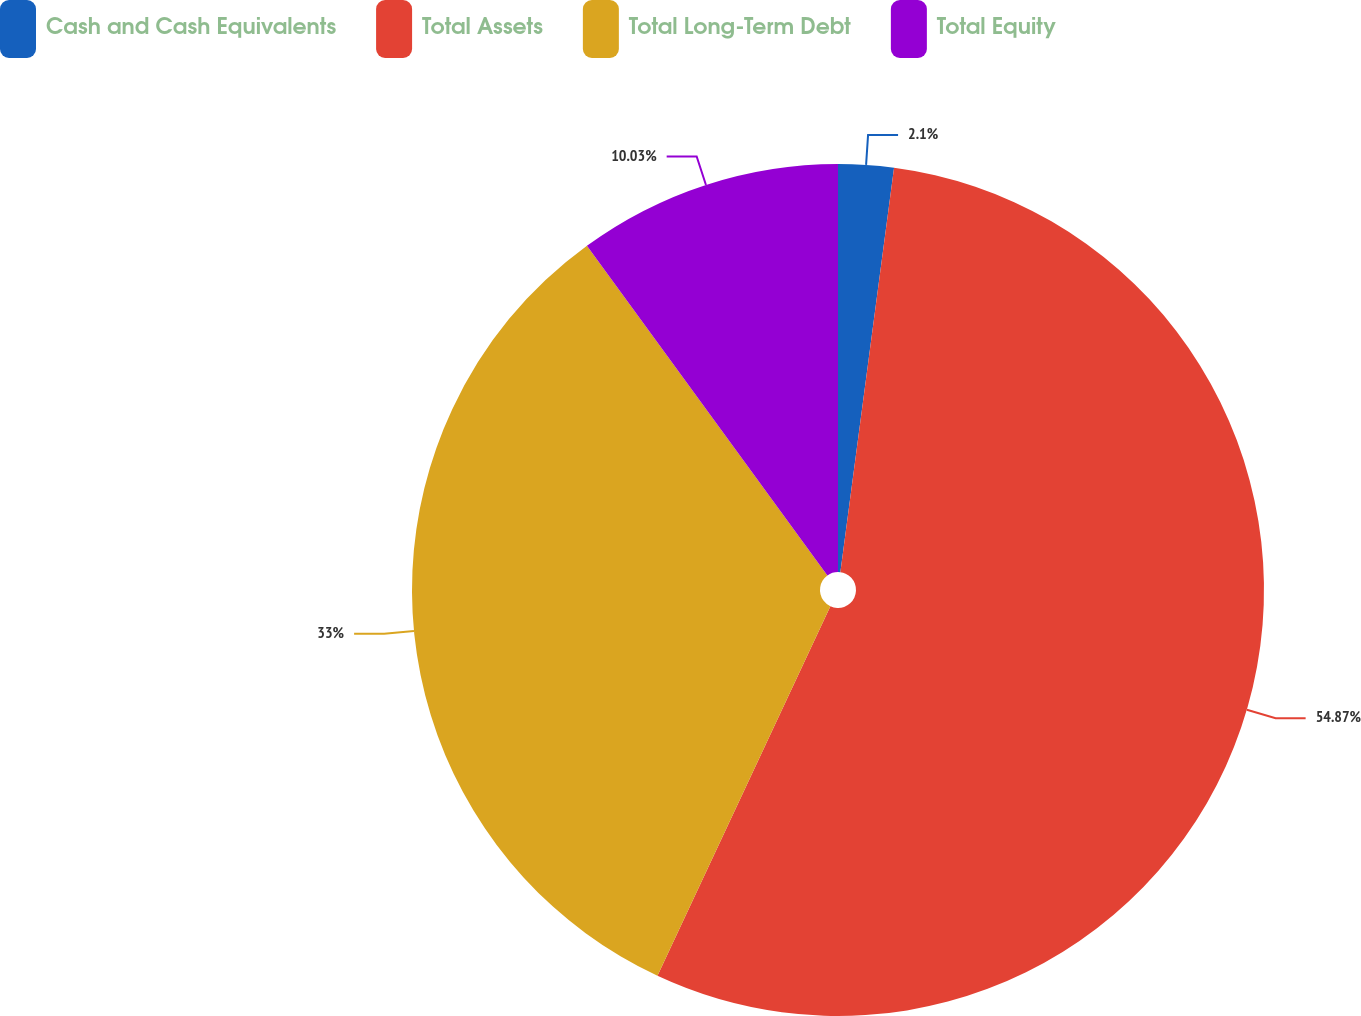<chart> <loc_0><loc_0><loc_500><loc_500><pie_chart><fcel>Cash and Cash Equivalents<fcel>Total Assets<fcel>Total Long-Term Debt<fcel>Total Equity<nl><fcel>2.1%<fcel>54.86%<fcel>33.0%<fcel>10.03%<nl></chart> 